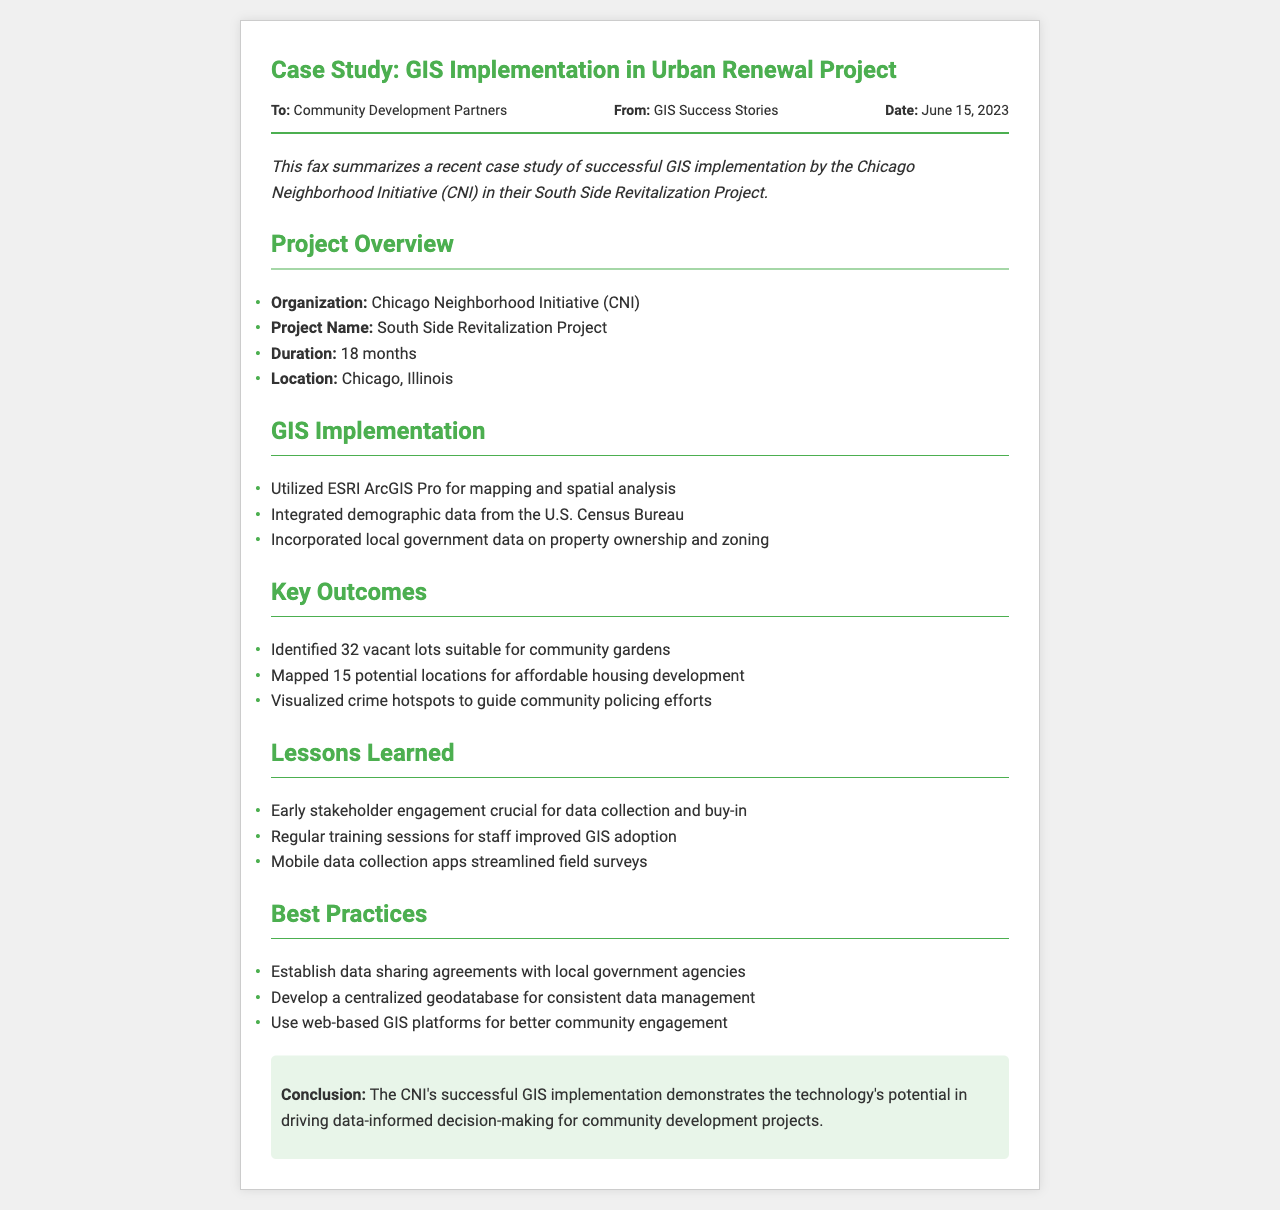What is the organization involved in the project? The organization leading the project is listed in the Project Overview section.
Answer: Chicago Neighborhood Initiative (CNI) What is the duration of the project? Duration is clearly mentioned in the Project Overview section.
Answer: 18 months How many vacant lots were identified for community gardens? The total number of vacant lots is found in the Key Outcomes section.
Answer: 32 What software was utilized for mapping and spatial analysis? The software used is specified in the GIS Implementation section.
Answer: ESRI ArcGIS Pro What is a key lesson learned regarding stakeholder engagement? The lesson about stakeholder engagement is found in the Lessons Learned section.
Answer: Early stakeholder engagement crucial for data collection and buy-in How was the GIS adoption among staff improved? The explanation regarding staff improvement is found in the Lessons Learned section.
Answer: Regular training sessions What type of agreements should be established with local government agencies? The type of agreements mentioned is in the Best Practices section.
Answer: Data sharing agreements Which city was the project located in? The location of the project is specified in the Project Overview section.
Answer: Chicago, Illinois What was the primary purpose of the project? The overall goal of the project can be inferred from the introduction and case study overview.
Answer: Revitalization What conclusion is drawn from the case study? The conclusion summarizes the impact of GIS on community development projects.
Answer: The technology's potential in driving data-informed decision-making 